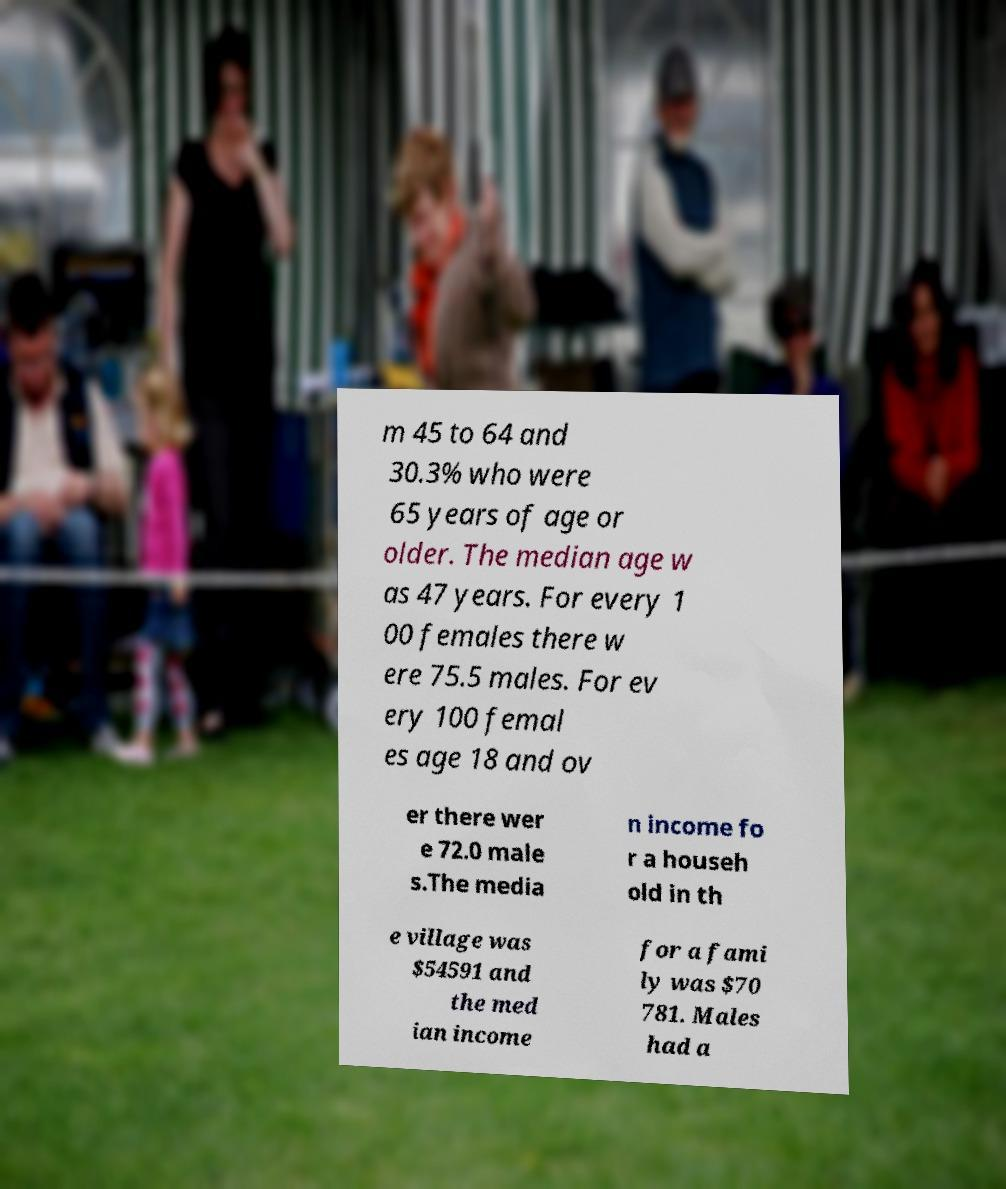I need the written content from this picture converted into text. Can you do that? m 45 to 64 and 30.3% who were 65 years of age or older. The median age w as 47 years. For every 1 00 females there w ere 75.5 males. For ev ery 100 femal es age 18 and ov er there wer e 72.0 male s.The media n income fo r a househ old in th e village was $54591 and the med ian income for a fami ly was $70 781. Males had a 